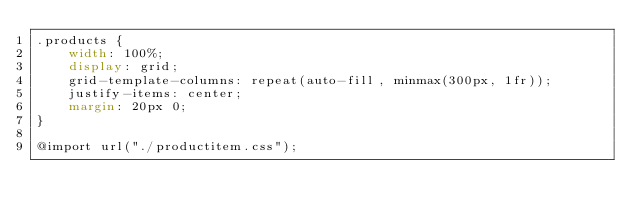<code> <loc_0><loc_0><loc_500><loc_500><_CSS_>.products {
    width: 100%;
    display: grid;
    grid-template-columns: repeat(auto-fill, minmax(300px, 1fr));
    justify-items: center;
    margin: 20px 0;
}

@import url("./productitem.css");</code> 